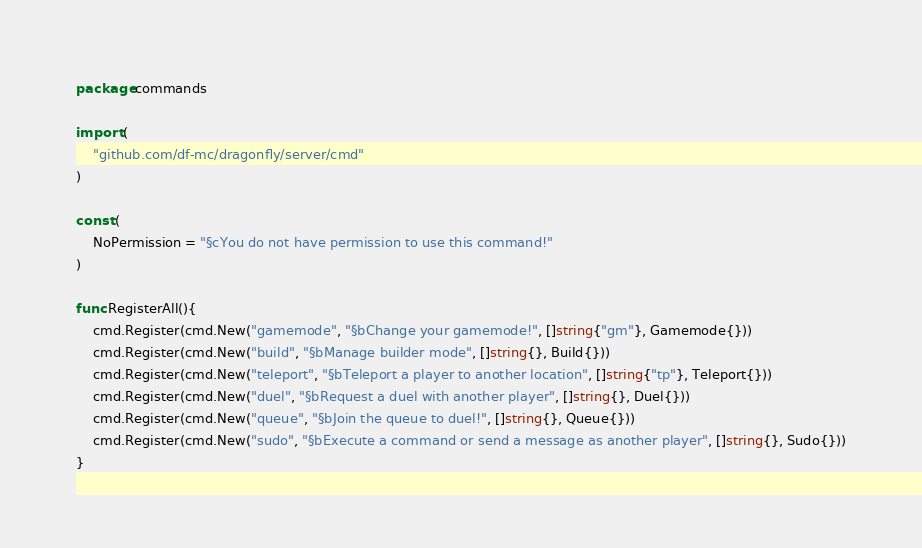<code> <loc_0><loc_0><loc_500><loc_500><_Go_>package commands

import (
	"github.com/df-mc/dragonfly/server/cmd"
)

const (
	NoPermission = "§cYou do not have permission to use this command!"
)

func RegisterAll(){
	cmd.Register(cmd.New("gamemode", "§bChange your gamemode!", []string{"gm"}, Gamemode{}))
	cmd.Register(cmd.New("build", "§bManage builder mode", []string{}, Build{}))
	cmd.Register(cmd.New("teleport", "§bTeleport a player to another location", []string{"tp"}, Teleport{}))
	cmd.Register(cmd.New("duel", "§bRequest a duel with another player", []string{}, Duel{}))
	cmd.Register(cmd.New("queue", "§bJoin the queue to duel!", []string{}, Queue{}))
	cmd.Register(cmd.New("sudo", "§bExecute a command or send a message as another player", []string{}, Sudo{}))
}</code> 